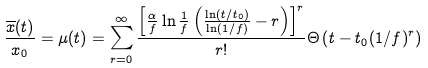Convert formula to latex. <formula><loc_0><loc_0><loc_500><loc_500>\frac { \overline { x } ( t ) } { x _ { 0 } } = \mu ( t ) = \sum _ { r = 0 } ^ { \infty } \frac { \left [ \frac { \alpha } { f } \ln \frac { 1 } { f } \left ( \frac { \ln ( t / t _ { 0 } ) } { \ln ( 1 / f ) } - r \right ) \right ] ^ { r } } { r ! } \Theta \left ( t - t _ { 0 } ( 1 / f ) ^ { r } \right )</formula> 